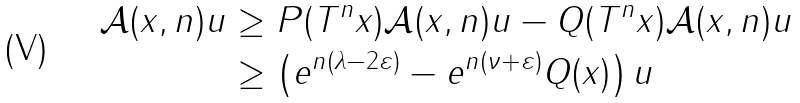<formula> <loc_0><loc_0><loc_500><loc_500>\| \mathcal { A } ( x , n ) u \| & \geq \| P ( T ^ { n } x ) \mathcal { A } ( x , n ) u \| - \| Q ( T ^ { n } x ) \mathcal { A } ( x , n ) u \| \\ & \geq \left ( e ^ { n ( \lambda - 2 \varepsilon ) } - e ^ { n ( \nu + \varepsilon ) } \| Q ( x ) \| \right ) \| u \|</formula> 